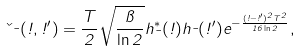<formula> <loc_0><loc_0><loc_500><loc_500>\kappa _ { \mu } ( \omega , \omega ^ { \prime } ) = \frac { T } { 2 } \sqrt { \frac { \pi } { \ln 2 } } h ^ { \ast } _ { \mu } ( \omega ) h _ { \mu } ( \omega ^ { \prime } ) e ^ { - \frac { ( \omega - \omega ^ { \prime } ) ^ { 2 } T ^ { 2 } } { 1 6 \ln 2 } } ,</formula> 